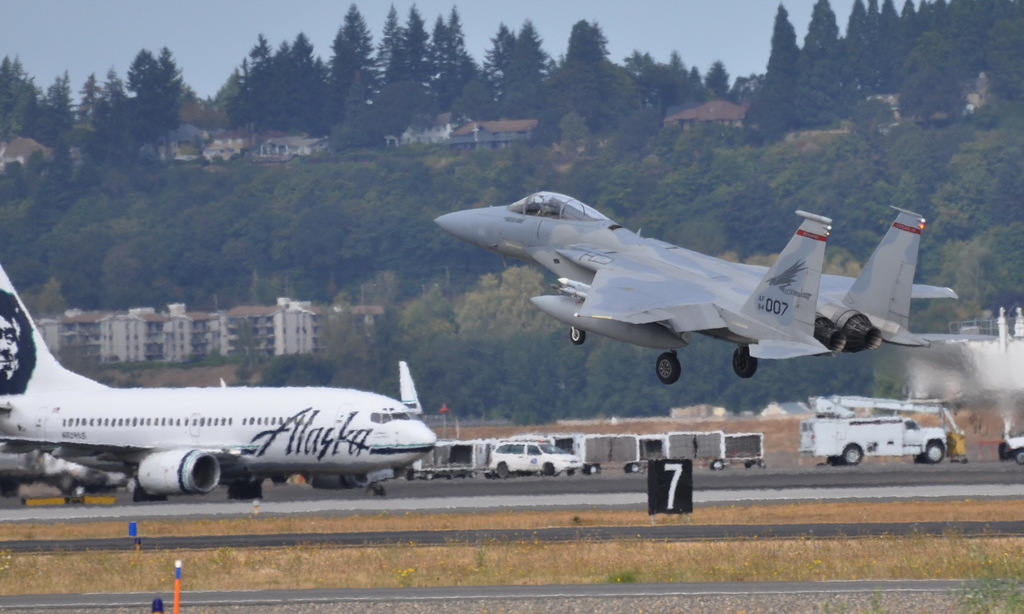Provide a one-sentence caption for the provided image.
Reference OCR token: CA, oe, TH, 007, ......****, HILY, Macka An Alaska plane is grounded as a jet takes off. 